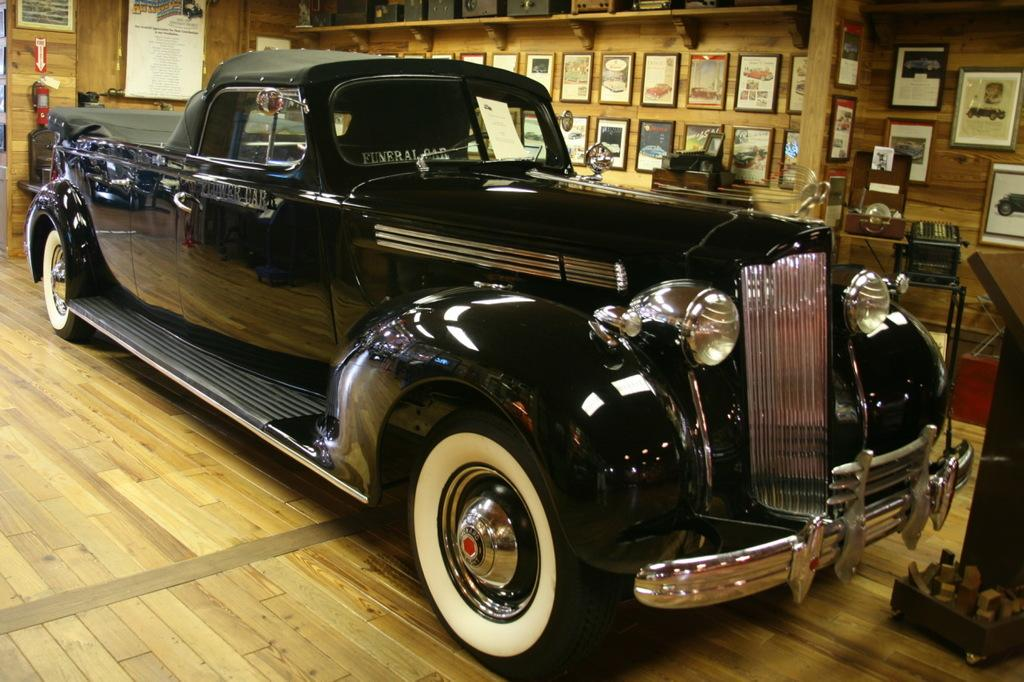What is the main subject of the image? There is a car in the image. What color is the car? The car is black. What can be seen in the background of the image? There are frames attached to a wooden wall in the background. What is the color of the wooden wall? The wall is brown. How does the ink on the wall cause the car to change color? There is no ink on the wall in the image, and the car's color does not change. 